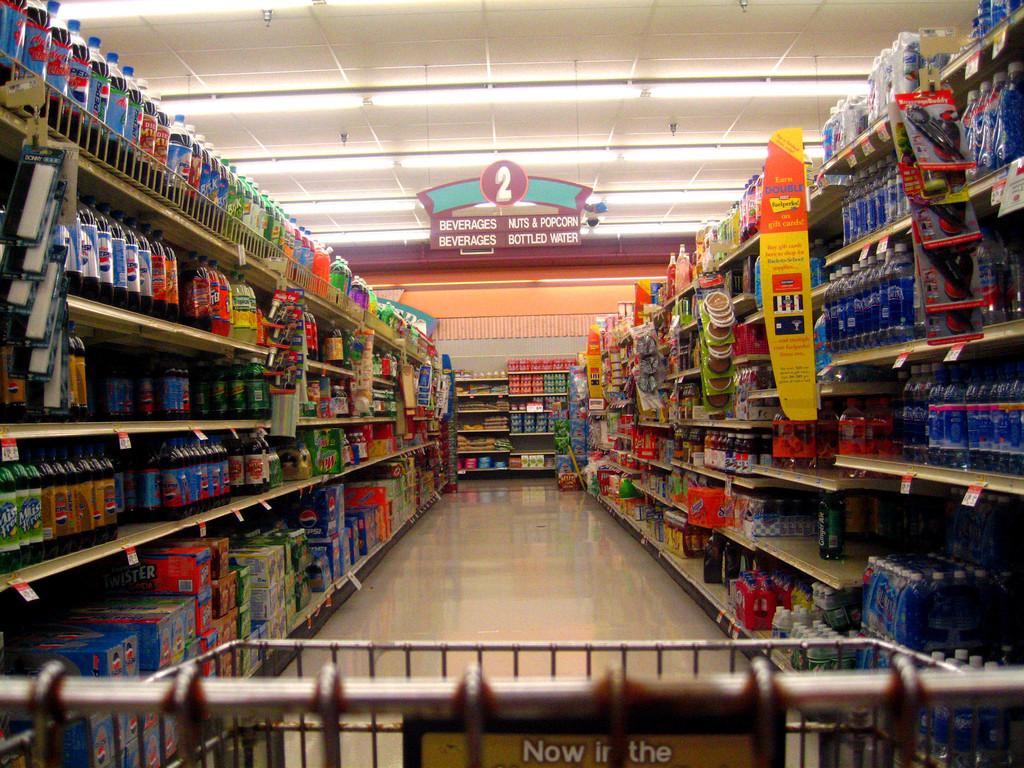Do they sell nuts in this aisle?
Provide a succinct answer. Yes. 